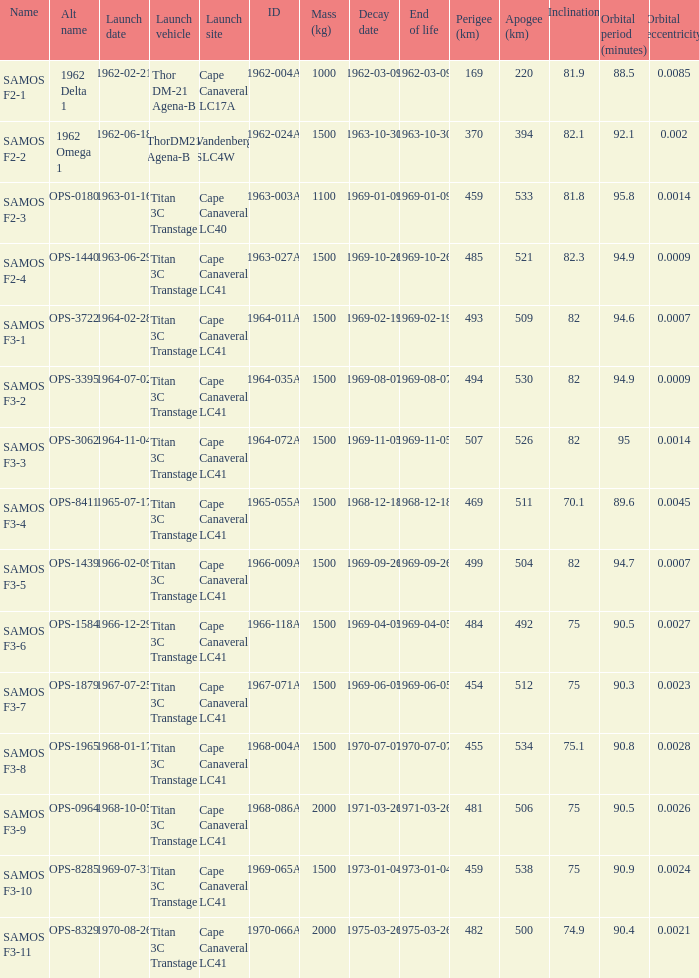What was the maximum perigee on 1969-01-09? 459.0. 